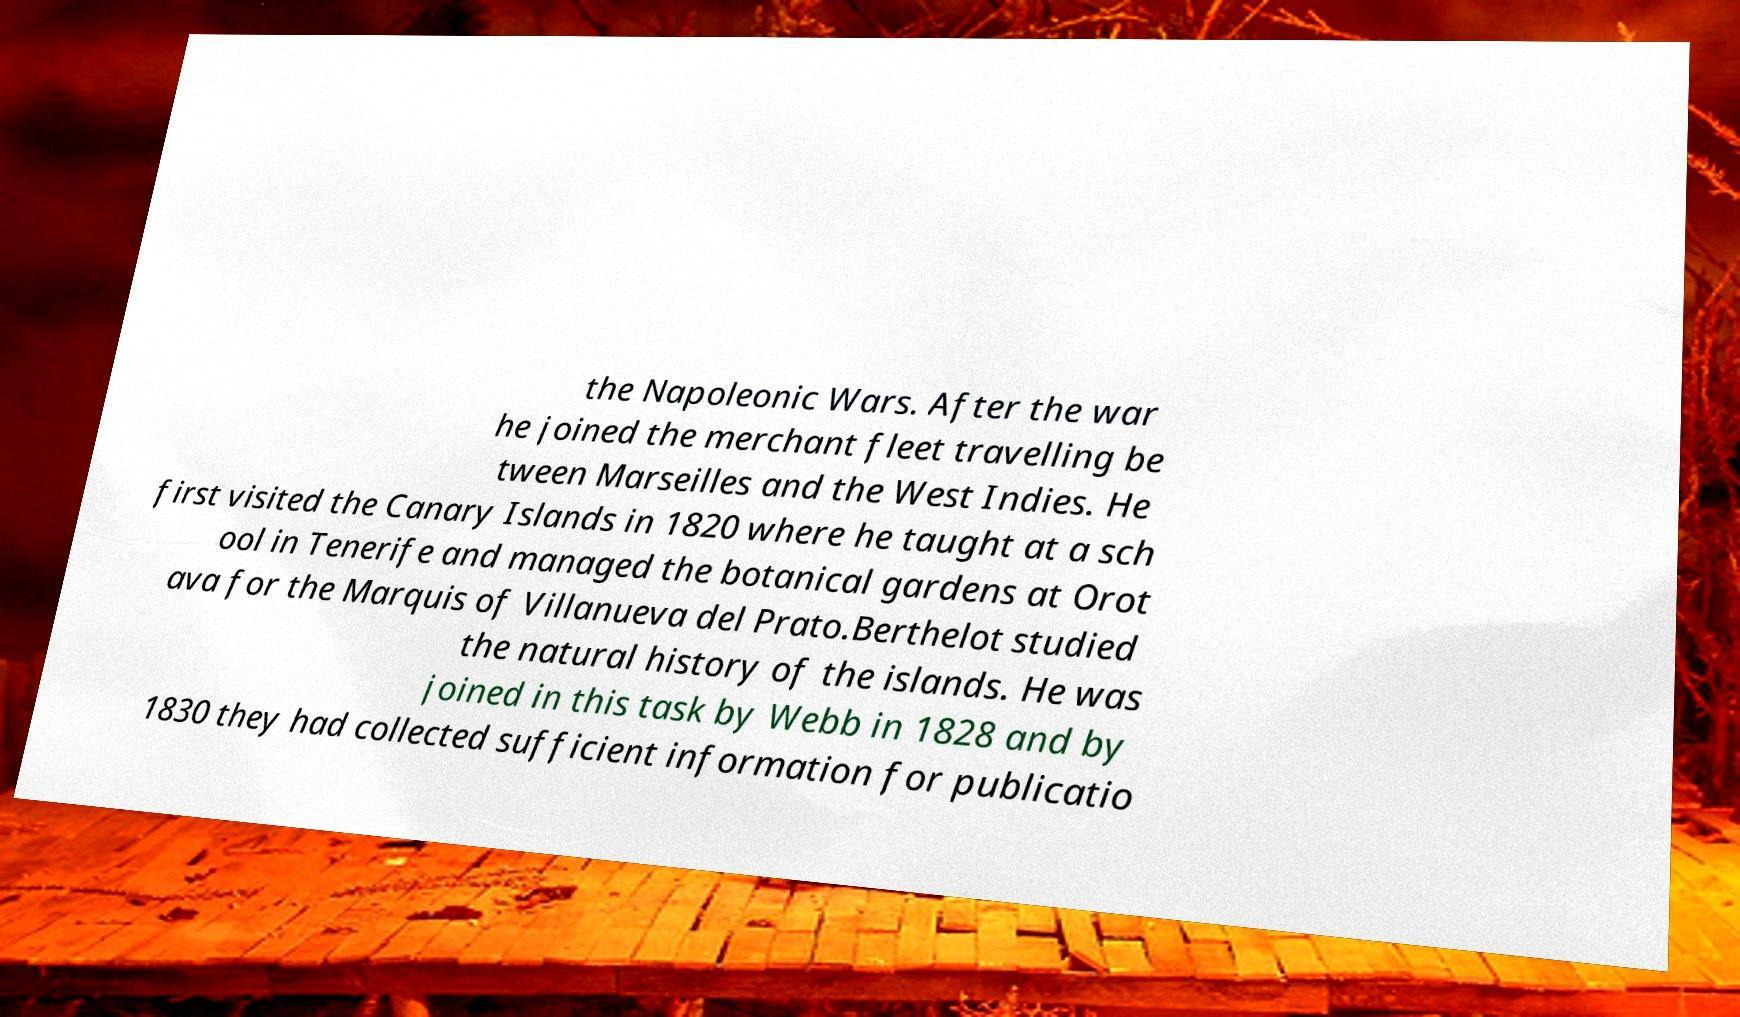Please read and relay the text visible in this image. What does it say? the Napoleonic Wars. After the war he joined the merchant fleet travelling be tween Marseilles and the West Indies. He first visited the Canary Islands in 1820 where he taught at a sch ool in Tenerife and managed the botanical gardens at Orot ava for the Marquis of Villanueva del Prato.Berthelot studied the natural history of the islands. He was joined in this task by Webb in 1828 and by 1830 they had collected sufficient information for publicatio 